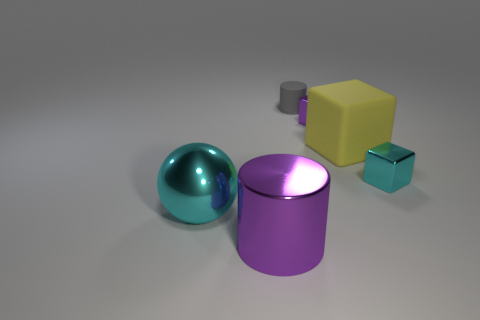What number of shiny cylinders are behind the purple cylinder?
Offer a very short reply. 0. How many objects are the same color as the ball?
Give a very brief answer. 1. Is the material of the object that is to the left of the metallic cylinder the same as the small cyan cube?
Your answer should be compact. Yes. What number of small purple blocks have the same material as the big cyan object?
Your answer should be very brief. 1. Is the number of cyan balls behind the cyan metal cube greater than the number of big cyan balls?
Your answer should be compact. No. There is a shiny object that is the same color as the big metal ball; what is its size?
Offer a terse response. Small. Is there another metallic object of the same shape as the tiny purple thing?
Offer a very short reply. Yes. How many things are blue shiny cylinders or purple shiny cylinders?
Your response must be concise. 1. There is a matte object right of the cylinder that is behind the cyan metallic sphere; how many tiny shiny things are behind it?
Your response must be concise. 1. There is a tiny cyan thing that is the same shape as the big yellow thing; what is it made of?
Give a very brief answer. Metal. 